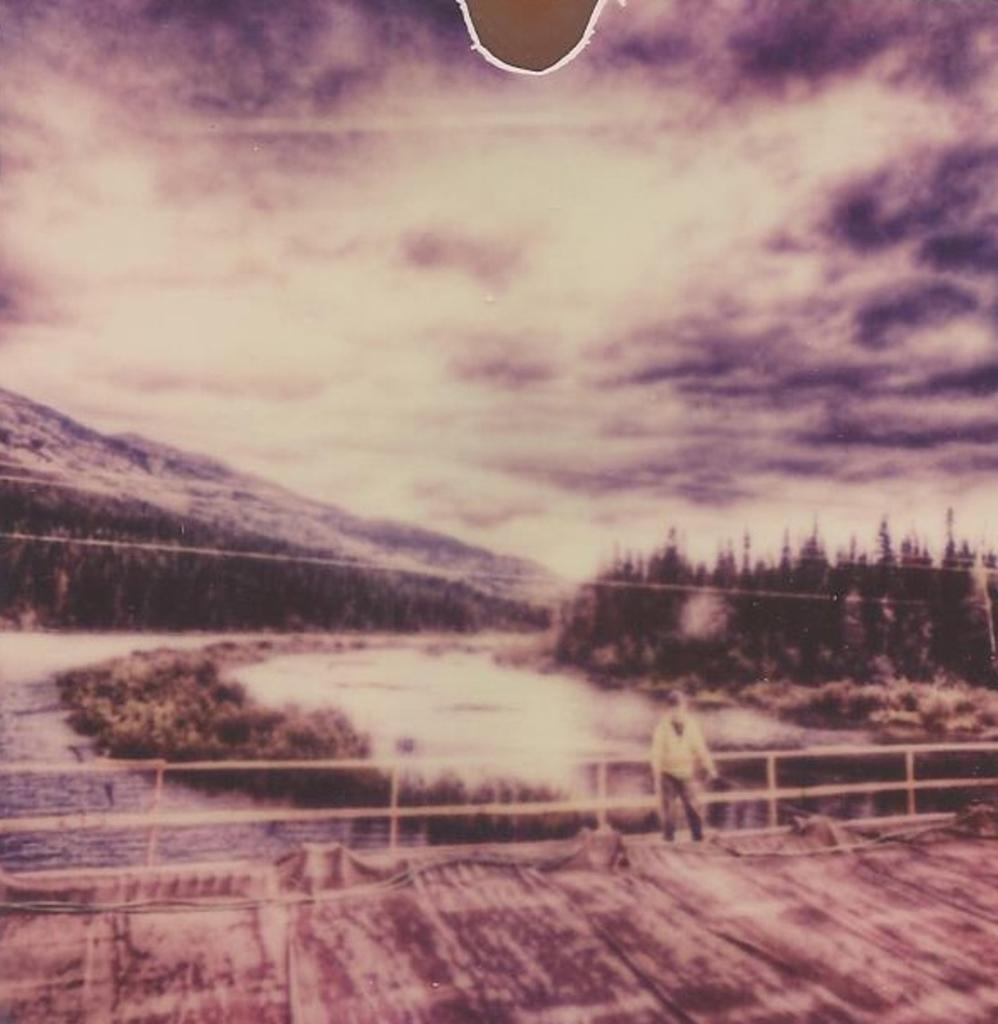Could you give a brief overview of what you see in this image? This looks like an edited image. Here is a person standing. I think this is the bridge. Here is the water. These are the trees. I think this is a hill. This looks like the sky. 